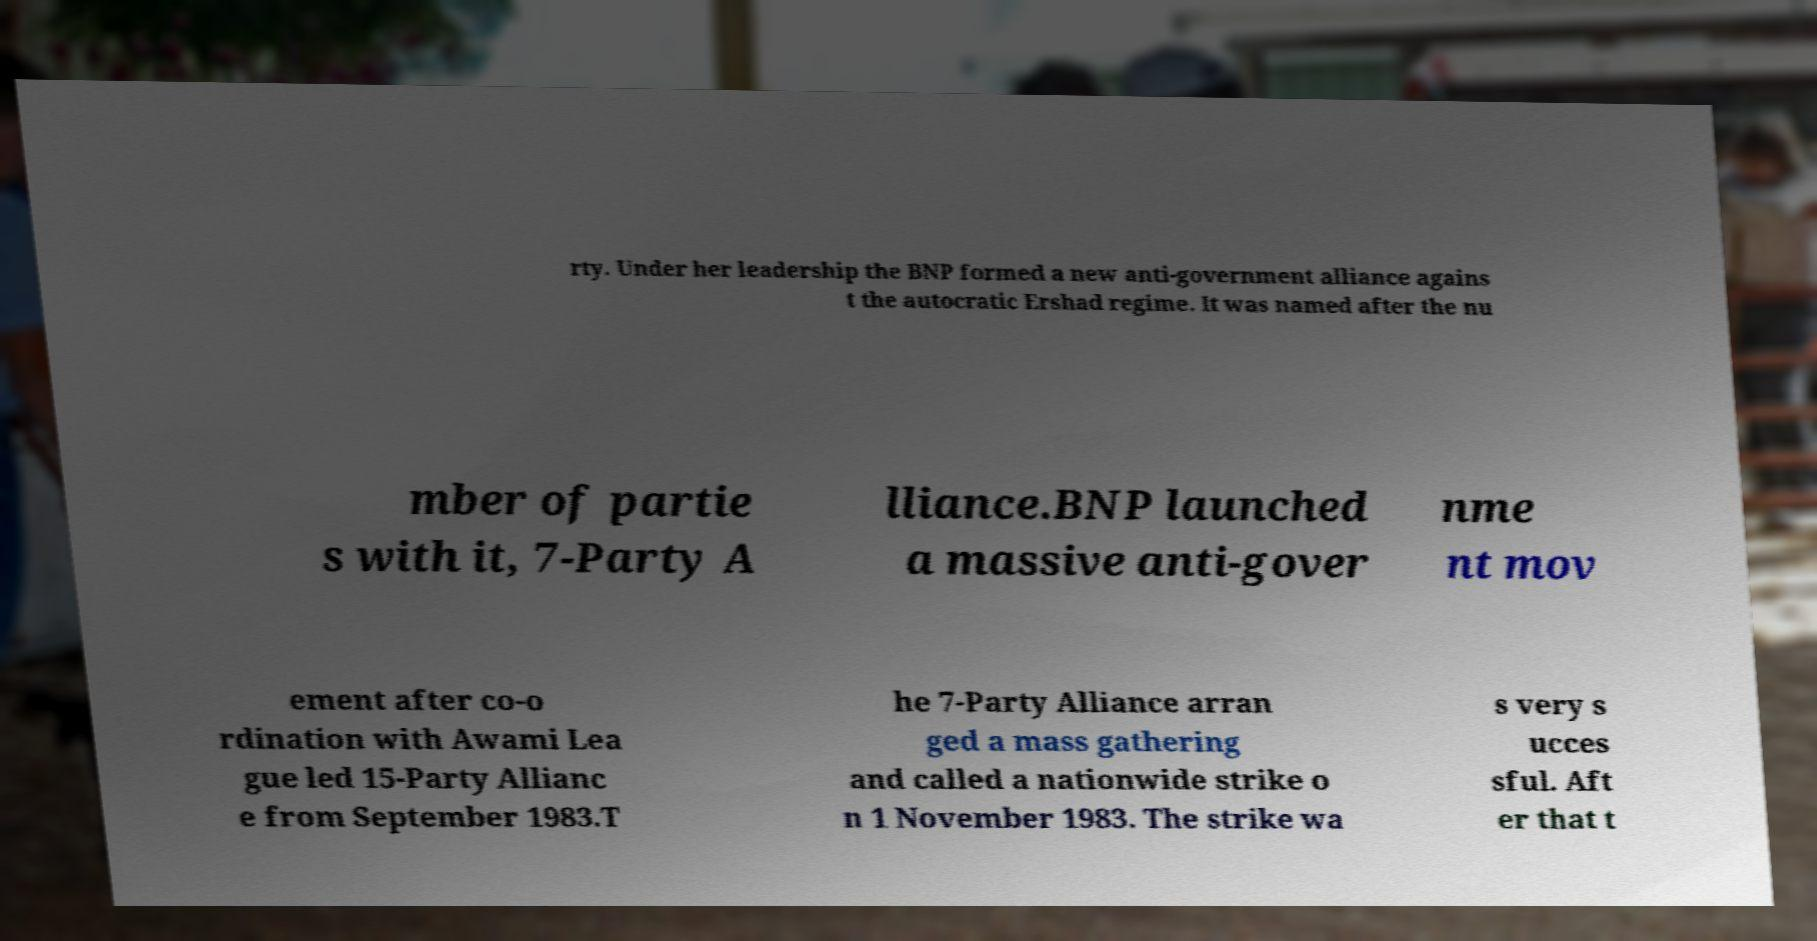Please read and relay the text visible in this image. What does it say? rty. Under her leadership the BNP formed a new anti-government alliance agains t the autocratic Ershad regime. It was named after the nu mber of partie s with it, 7-Party A lliance.BNP launched a massive anti-gover nme nt mov ement after co-o rdination with Awami Lea gue led 15-Party Allianc e from September 1983.T he 7-Party Alliance arran ged a mass gathering and called a nationwide strike o n 1 November 1983. The strike wa s very s ucces sful. Aft er that t 